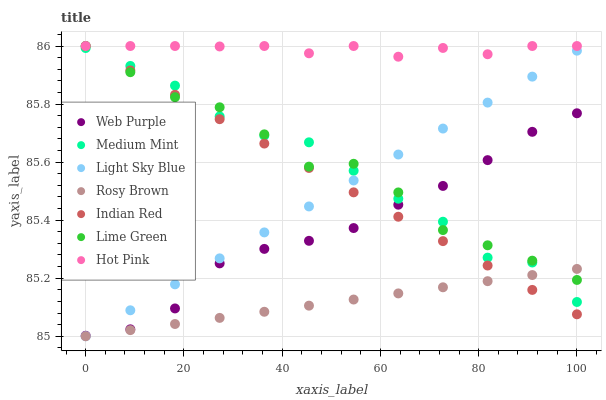Does Rosy Brown have the minimum area under the curve?
Answer yes or no. Yes. Does Hot Pink have the maximum area under the curve?
Answer yes or no. Yes. Does Hot Pink have the minimum area under the curve?
Answer yes or no. No. Does Rosy Brown have the maximum area under the curve?
Answer yes or no. No. Is Indian Red the smoothest?
Answer yes or no. Yes. Is Medium Mint the roughest?
Answer yes or no. Yes. Is Hot Pink the smoothest?
Answer yes or no. No. Is Hot Pink the roughest?
Answer yes or no. No. Does Rosy Brown have the lowest value?
Answer yes or no. Yes. Does Hot Pink have the lowest value?
Answer yes or no. No. Does Lime Green have the highest value?
Answer yes or no. Yes. Does Rosy Brown have the highest value?
Answer yes or no. No. Is Light Sky Blue less than Hot Pink?
Answer yes or no. Yes. Is Web Purple greater than Rosy Brown?
Answer yes or no. Yes. Does Medium Mint intersect Indian Red?
Answer yes or no. Yes. Is Medium Mint less than Indian Red?
Answer yes or no. No. Is Medium Mint greater than Indian Red?
Answer yes or no. No. Does Light Sky Blue intersect Hot Pink?
Answer yes or no. No. 